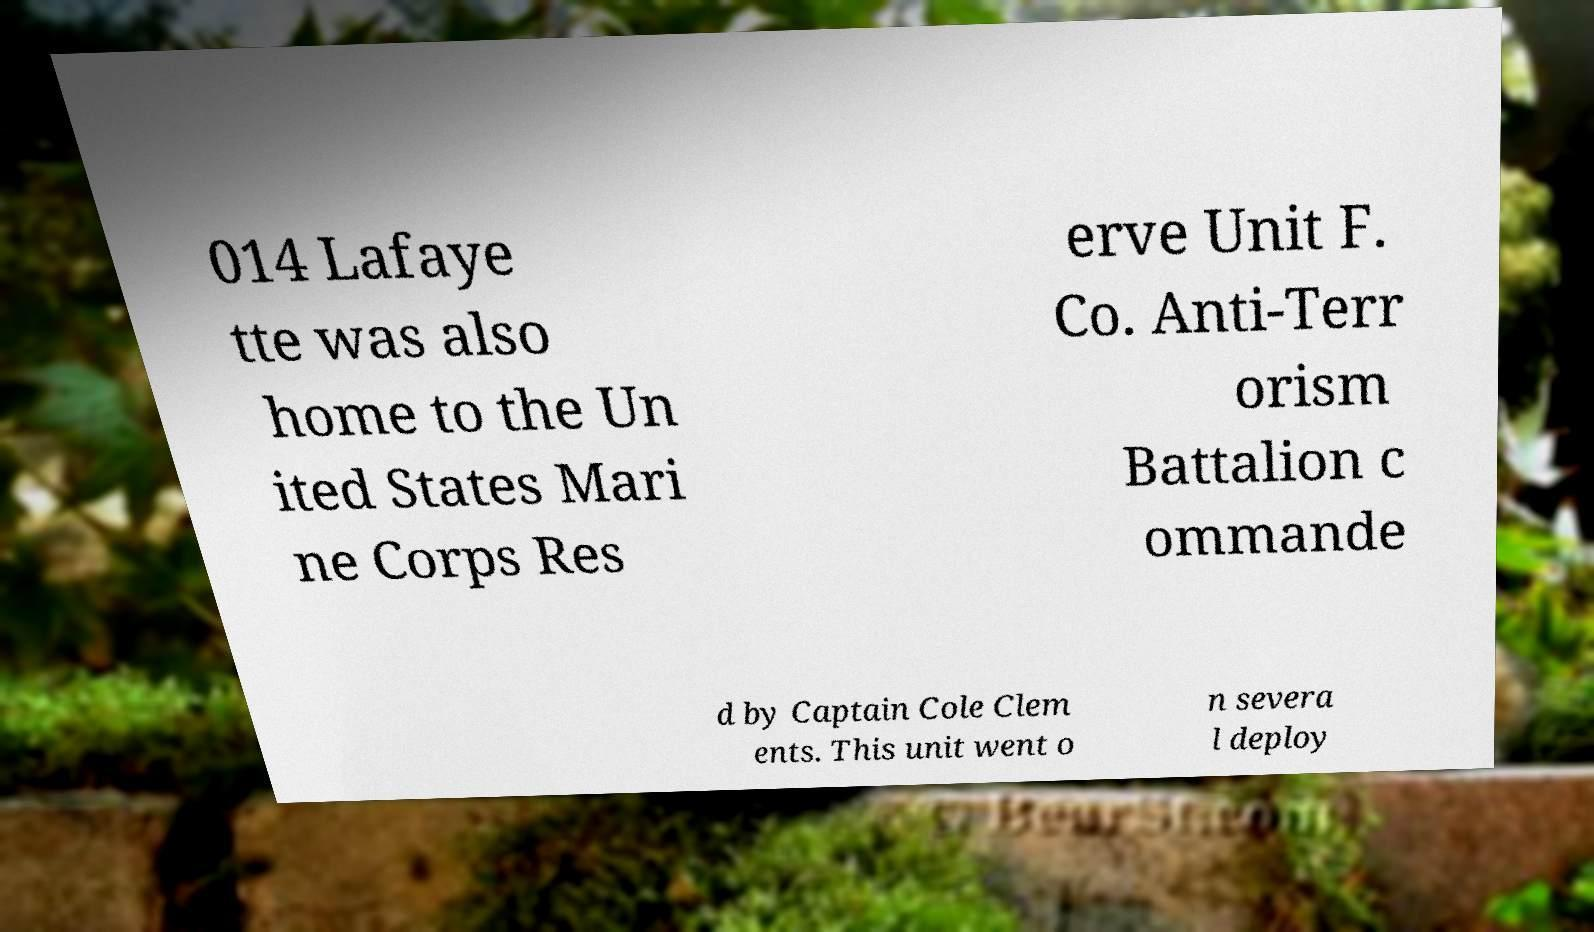Can you accurately transcribe the text from the provided image for me? 014 Lafaye tte was also home to the Un ited States Mari ne Corps Res erve Unit F. Co. Anti-Terr orism Battalion c ommande d by Captain Cole Clem ents. This unit went o n severa l deploy 